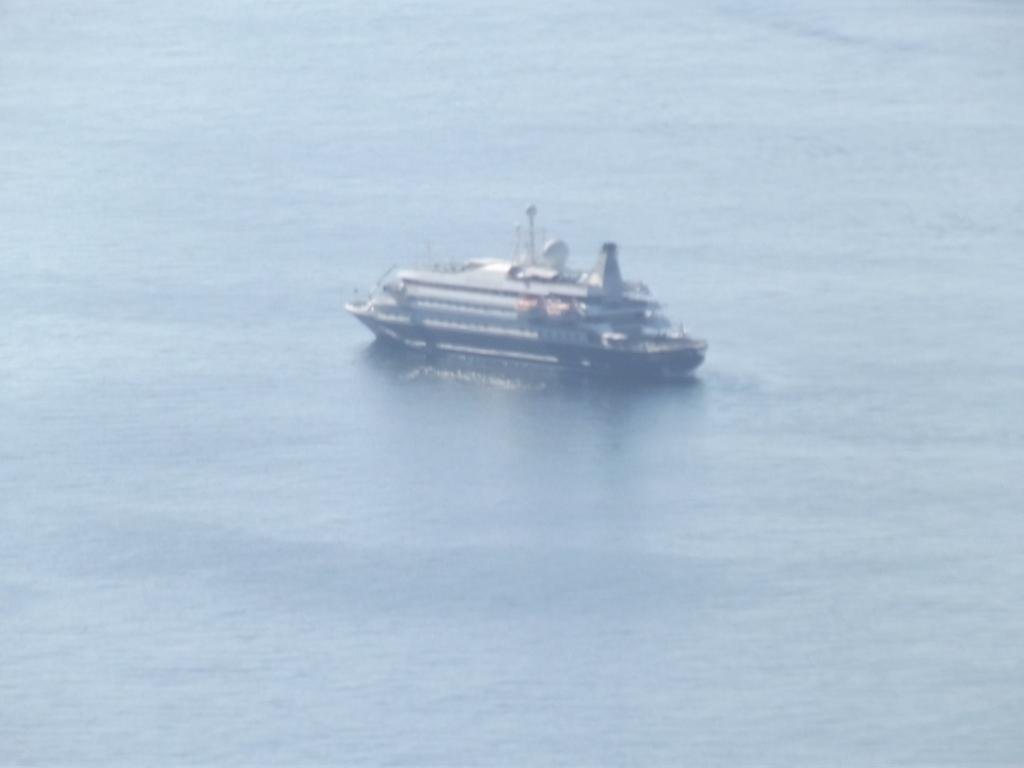What is the main setting of the image? The image depicts a sea. What can be seen in the sea? There is a ship in the sea. What type of stove can be seen on the ship in the image? There is no stove visible in the image; it only shows a ship in the sea. How many eggs are floating in the sea near the ship? There are no eggs present in the image; it only shows a ship in the sea. 